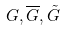Convert formula to latex. <formula><loc_0><loc_0><loc_500><loc_500>G , \overline { G } , \tilde { G }</formula> 